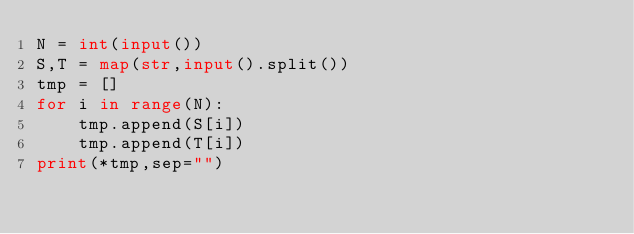Convert code to text. <code><loc_0><loc_0><loc_500><loc_500><_Python_>N = int(input())
S,T = map(str,input().split())
tmp = []
for i in range(N):
    tmp.append(S[i])
    tmp.append(T[i])
print(*tmp,sep="")</code> 